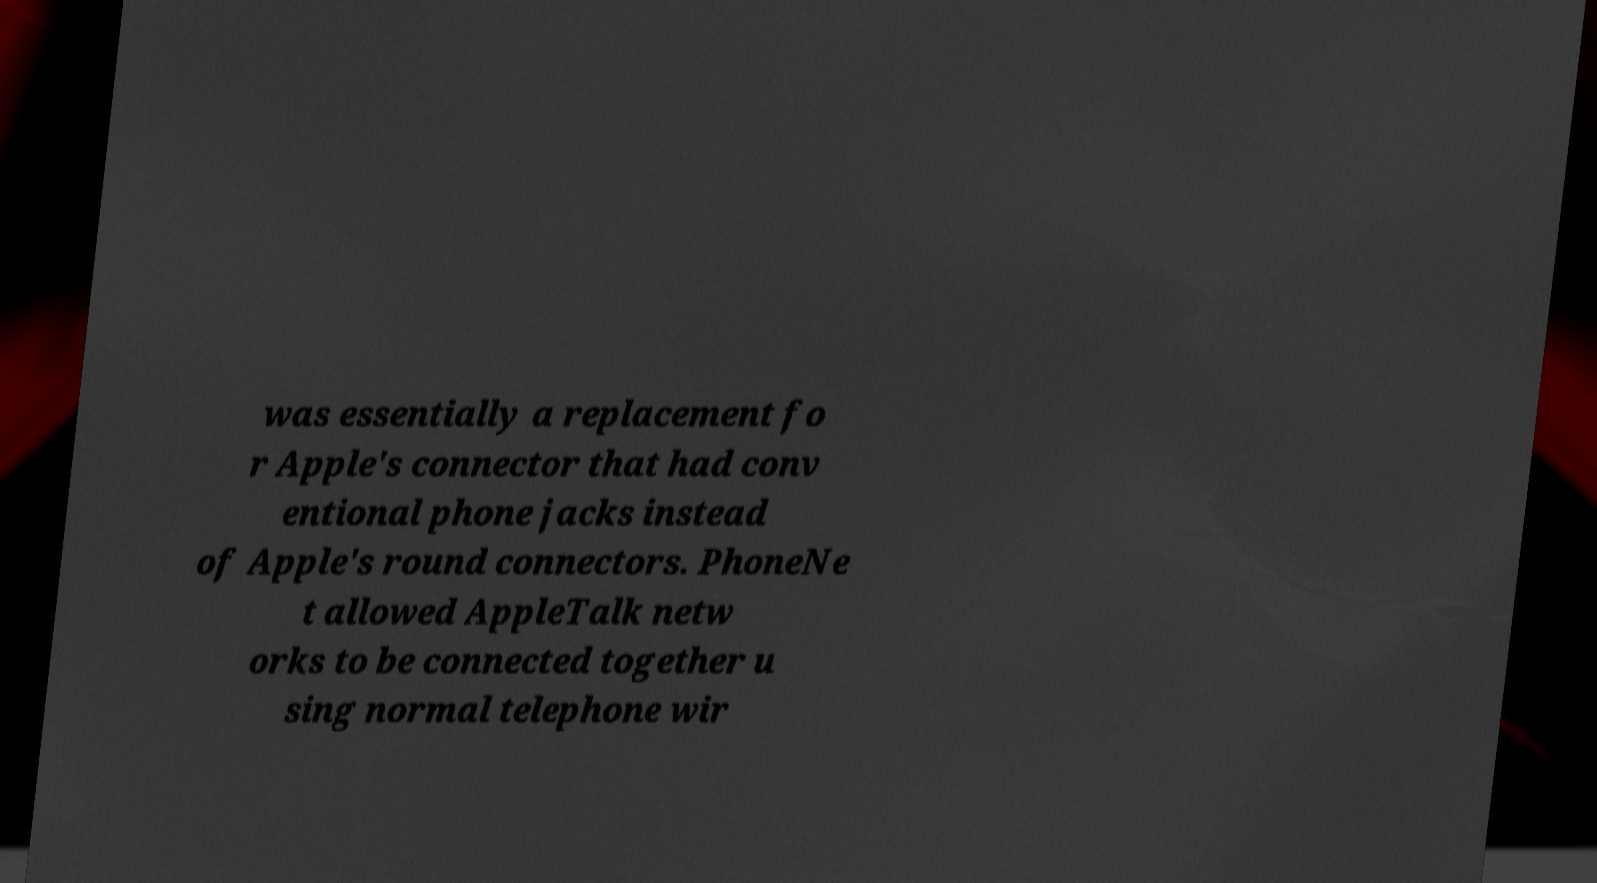For documentation purposes, I need the text within this image transcribed. Could you provide that? was essentially a replacement fo r Apple's connector that had conv entional phone jacks instead of Apple's round connectors. PhoneNe t allowed AppleTalk netw orks to be connected together u sing normal telephone wir 